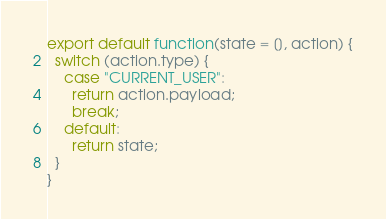Convert code to text. <code><loc_0><loc_0><loc_500><loc_500><_JavaScript_>export default function(state = [], action) {
  switch (action.type) {
    case "CURRENT_USER":
      return action.payload;
      break;
    default:
      return state;
  }
}
</code> 